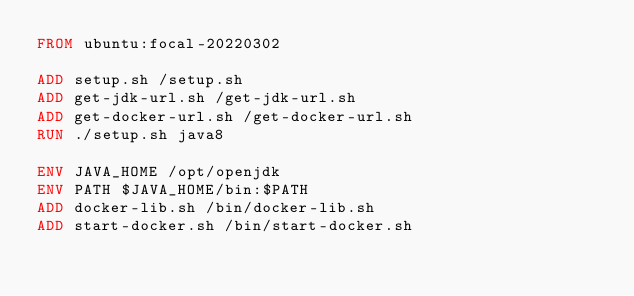<code> <loc_0><loc_0><loc_500><loc_500><_Dockerfile_>FROM ubuntu:focal-20220302

ADD setup.sh /setup.sh
ADD get-jdk-url.sh /get-jdk-url.sh
ADD get-docker-url.sh /get-docker-url.sh
RUN ./setup.sh java8

ENV JAVA_HOME /opt/openjdk
ENV PATH $JAVA_HOME/bin:$PATH
ADD docker-lib.sh /bin/docker-lib.sh
ADD start-docker.sh /bin/start-docker.sh
</code> 